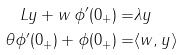<formula> <loc_0><loc_0><loc_500><loc_500>L y + w \, \phi ^ { \prime } ( 0 _ { + } ) = & \lambda y \\ \theta \phi ^ { \prime } ( 0 _ { + } ) + \phi ( 0 _ { + } ) = & \langle w , y \rangle</formula> 